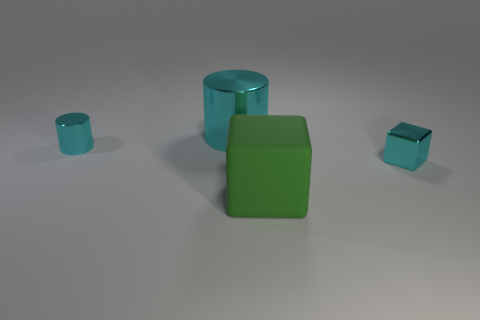Are there any other things that are made of the same material as the green thing?
Provide a succinct answer. No. What shape is the small metallic thing that is the same color as the tiny cylinder?
Provide a short and direct response. Cube. What is the size of the metallic cylinder that is the same color as the large metal thing?
Ensure brevity in your answer.  Small. Is there another small brown block made of the same material as the tiny block?
Offer a terse response. No. How many things are cyan metal things on the left side of the large green cube or tiny cyan things that are on the left side of the large cyan thing?
Offer a very short reply. 2. Is the shape of the large metallic object the same as the tiny thing that is on the left side of the green rubber block?
Offer a terse response. Yes. What number of other objects are the same shape as the large cyan object?
Offer a very short reply. 1. What number of objects are either small blue rubber balls or cyan metal cubes?
Provide a short and direct response. 1. Is the color of the metallic block the same as the large shiny object?
Keep it short and to the point. Yes. What is the shape of the small cyan thing behind the tiny cyan metal object that is right of the rubber thing?
Offer a very short reply. Cylinder. 